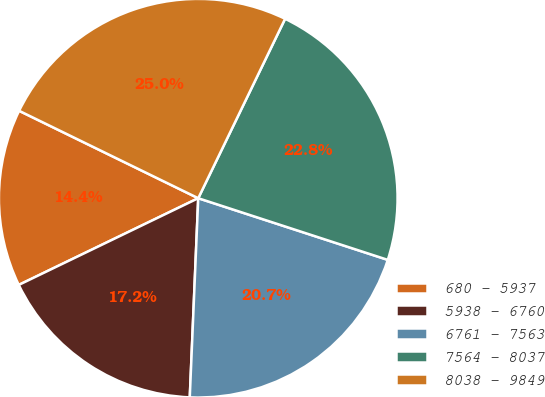Convert chart. <chart><loc_0><loc_0><loc_500><loc_500><pie_chart><fcel>680 - 5937<fcel>5938 - 6760<fcel>6761 - 7563<fcel>7564 - 8037<fcel>8038 - 9849<nl><fcel>14.39%<fcel>17.16%<fcel>20.67%<fcel>22.83%<fcel>24.95%<nl></chart> 